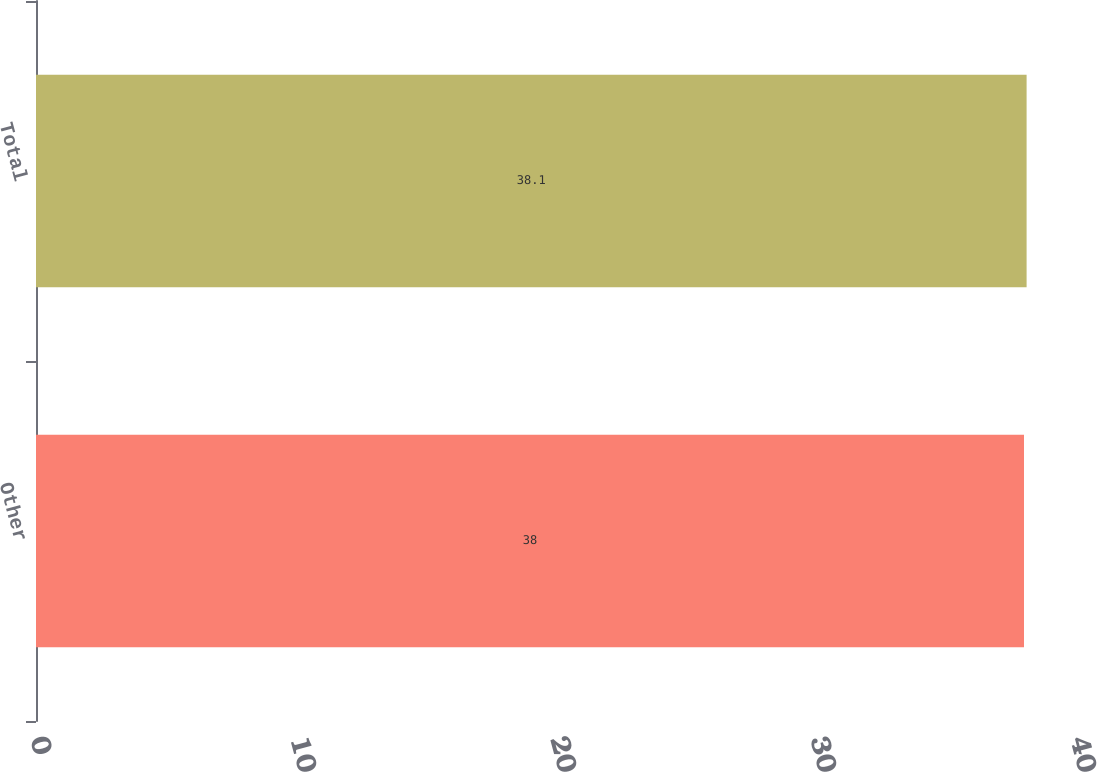<chart> <loc_0><loc_0><loc_500><loc_500><bar_chart><fcel>Other<fcel>Total<nl><fcel>38<fcel>38.1<nl></chart> 